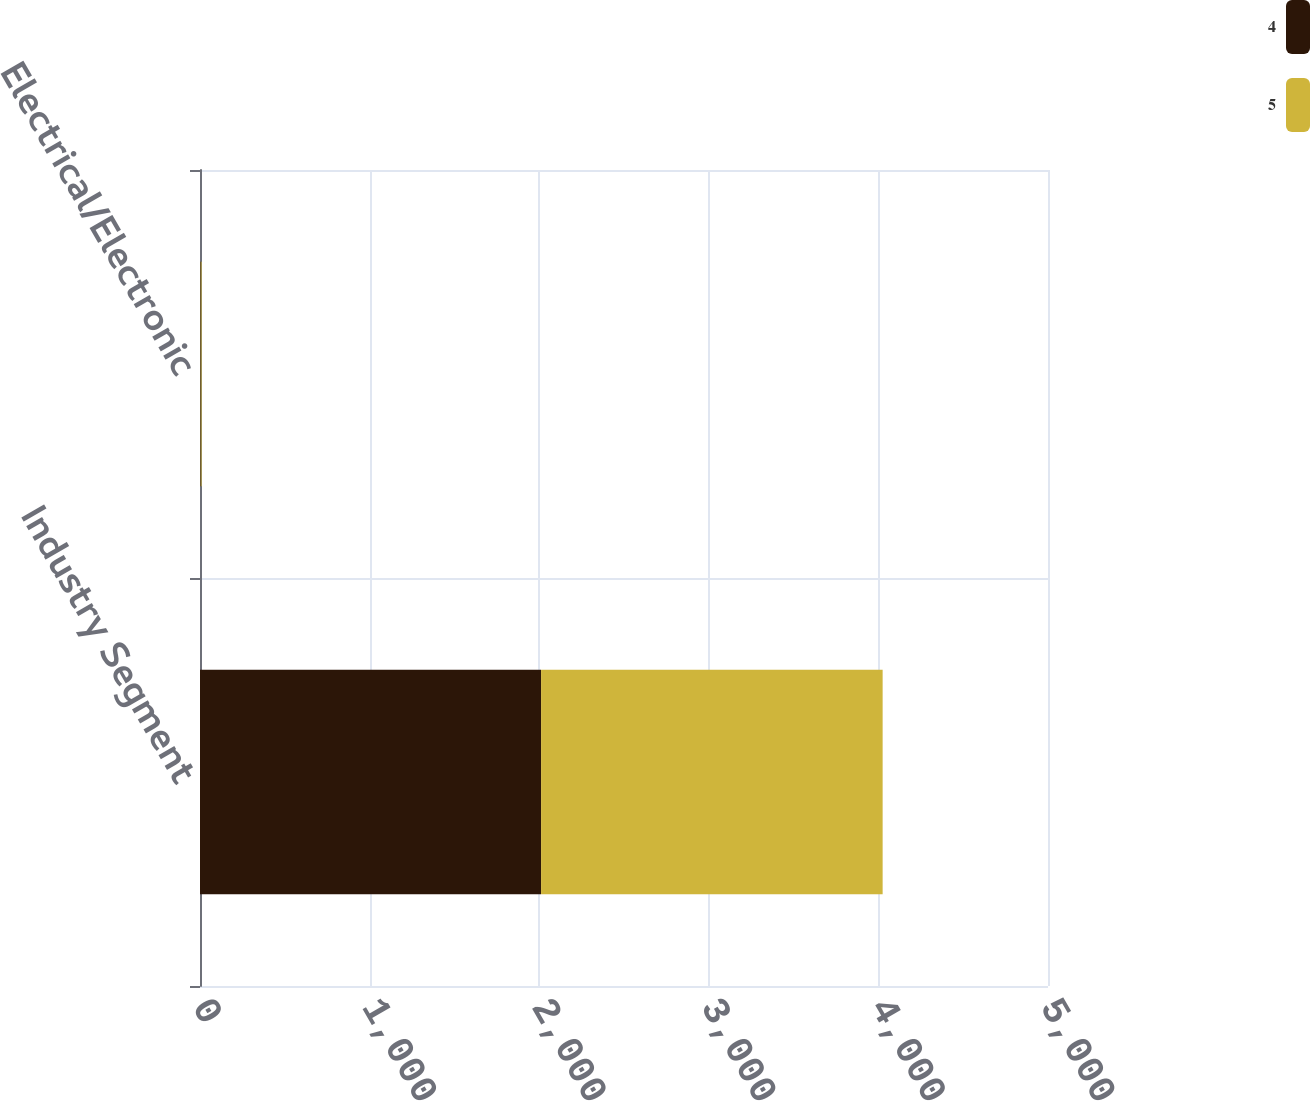<chart> <loc_0><loc_0><loc_500><loc_500><stacked_bar_chart><ecel><fcel>Industry Segment<fcel>Electrical/Electronic<nl><fcel>4<fcel>2011<fcel>4<nl><fcel>5<fcel>2014<fcel>5<nl></chart> 